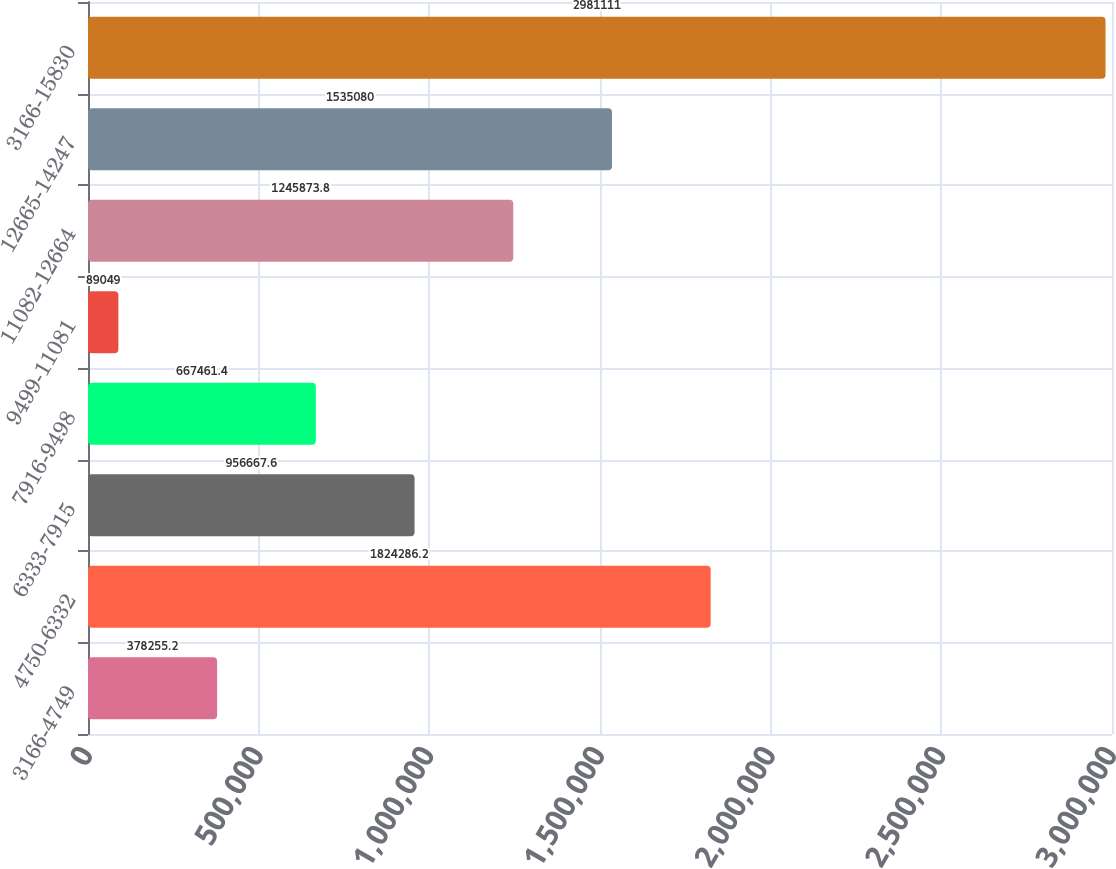Convert chart to OTSL. <chart><loc_0><loc_0><loc_500><loc_500><bar_chart><fcel>3166-4749<fcel>4750-6332<fcel>6333-7915<fcel>7916-9498<fcel>9499-11081<fcel>11082-12664<fcel>12665-14247<fcel>3166-15830<nl><fcel>378255<fcel>1.82429e+06<fcel>956668<fcel>667461<fcel>89049<fcel>1.24587e+06<fcel>1.53508e+06<fcel>2.98111e+06<nl></chart> 